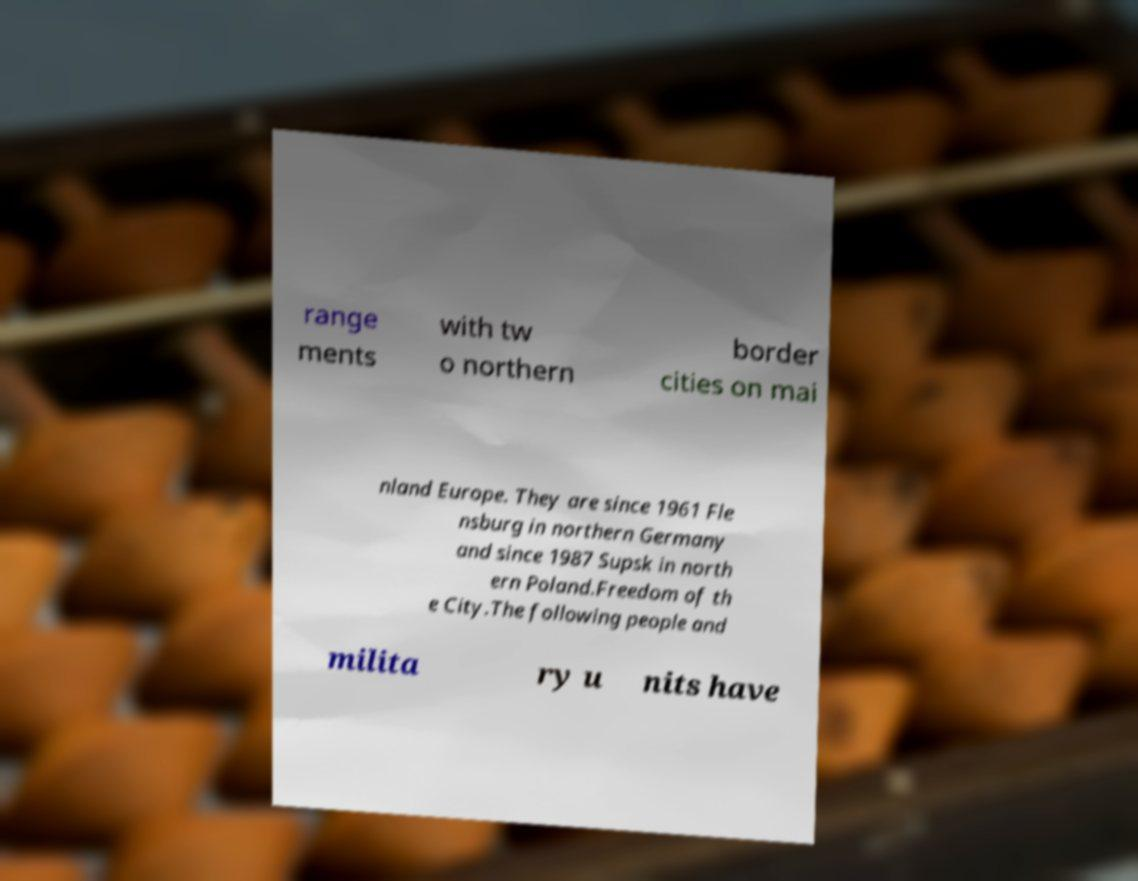What messages or text are displayed in this image? I need them in a readable, typed format. range ments with tw o northern border cities on mai nland Europe. They are since 1961 Fle nsburg in northern Germany and since 1987 Supsk in north ern Poland.Freedom of th e City.The following people and milita ry u nits have 